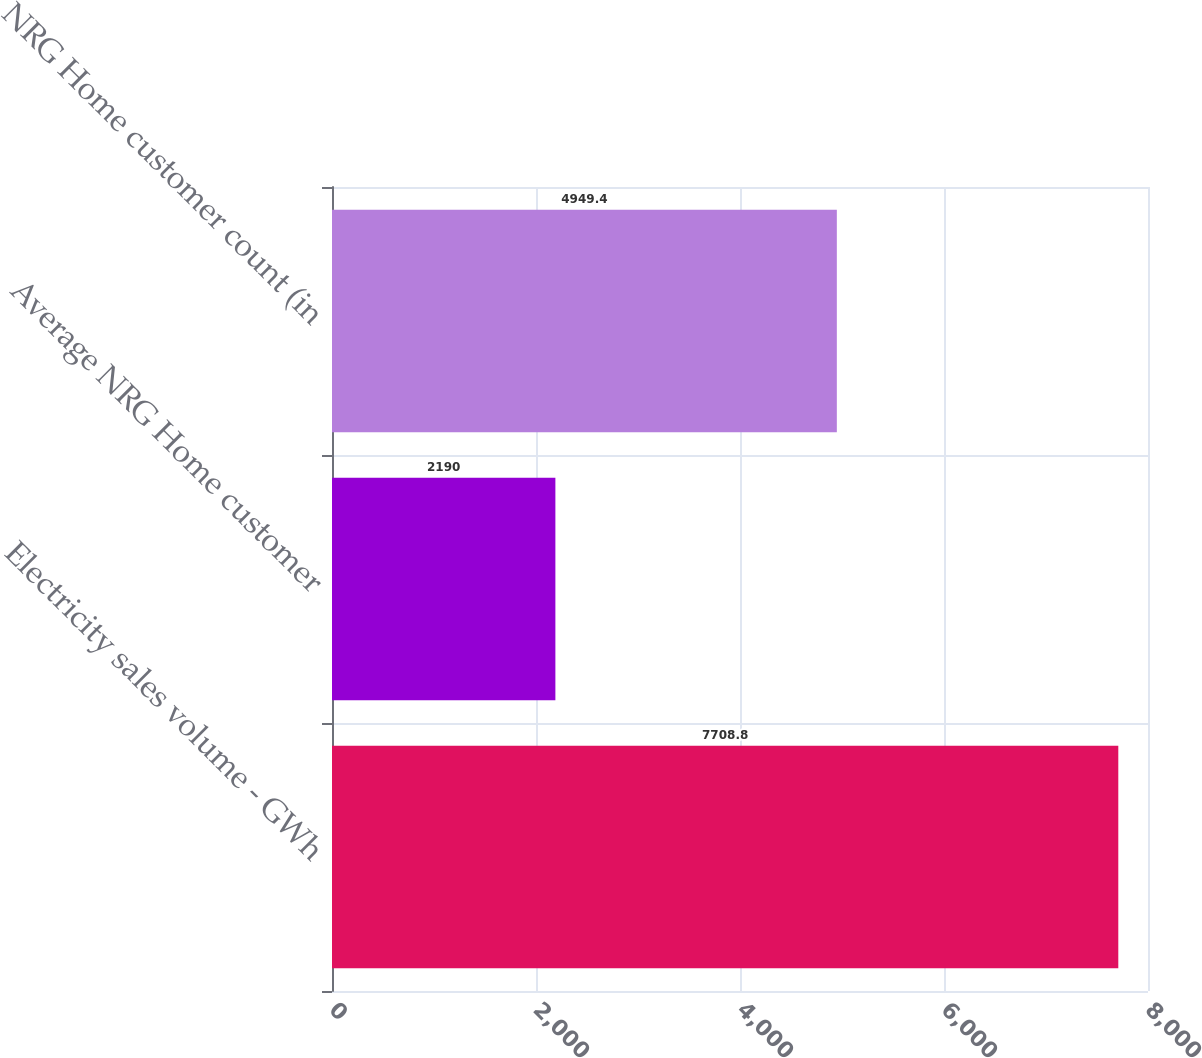Convert chart to OTSL. <chart><loc_0><loc_0><loc_500><loc_500><bar_chart><fcel>Electricity sales volume - GWh<fcel>Average NRG Home customer<fcel>NRG Home customer count (in<nl><fcel>7708.8<fcel>2190<fcel>4949.4<nl></chart> 